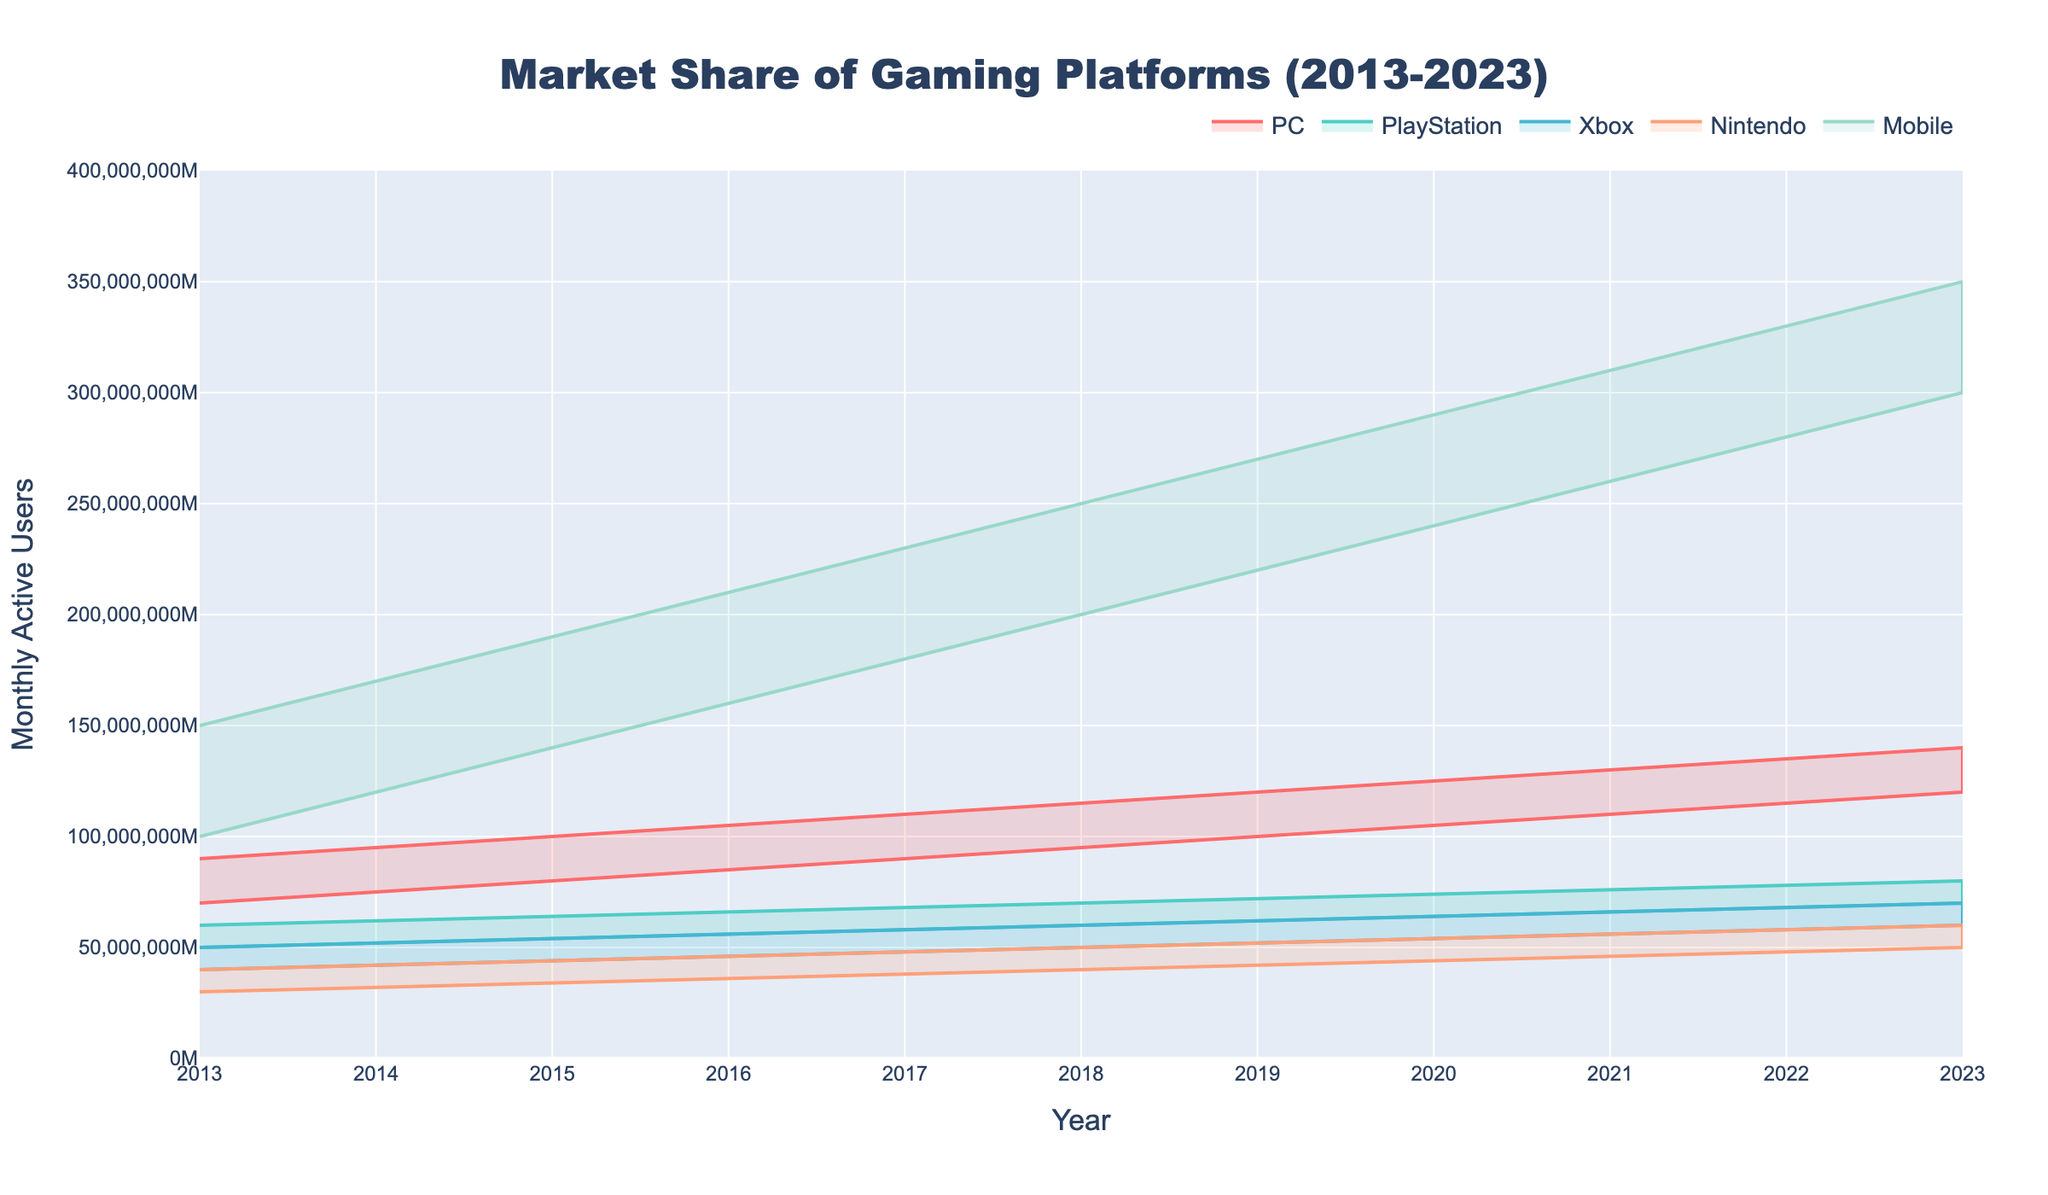Which platform has the highest maximum monthly active users in 2023? Looking at the plot for the year 2023, the Mobile platform's range extends up to 350 million monthly active users, which is the highest among all platforms.
Answer: Mobile What is the total range of monthly active users for the PC platform in 2020? For the PC platform in 2020, the range of monthly active users is from 105 million to 125 million. The total range is the difference between the maximum and minimum values: 125 million - 105 million.
Answer: 20 million Which platform showed the highest growth in maximum monthly active users from 2013 to 2023? By comparing the maximum monthly active users for each platform between 2013 and 2023, Mobile went from 150 million to 350 million, representing a growth of 200 million users, which is the highest growth among all platforms.
Answer: Mobile How much did the minimum monthly active users for the Nintendo platform increase from 2017 to 2020? For Nintendo, the minimum monthly active users were 38 million in 2017 and 44 million in 2020. The increase is calculated as 44 million - 38 million.
Answer: 6 million In which year did the PlayStation platform reach a minimum monthly active user count of 60 million? Examining the PlayStation area for a minimum of 60 million monthly active users, it occurred in the year 2018.
Answer: 2018 What was the minimum user range for Xbox in 2015, and how does it compare to Nintendo's minimum user range in the same year? The minimum monthly active users for Xbox in 2015 were 44 million, and for Nintendo, it was 34 million. Comparing the two, Xbox had 10 million more users than Nintendo.
Answer: 10 million more Which platform had the smallest growth in maximum monthly active users between 2013 and 2023? By comparing growth for all platforms: PC grew by 50 million, PlayStation by 20 million, Xbox by 20 million, Nintendo by 20 million, and Mobile by 200 million, PlayStation, Xbox, and Nintendo all had the smallest growth of 20 million each.
Answer: PlayStation, Xbox, and Nintendo What was the range of monthly active users for Mobile in 2016? The range for Mobile in 2016 extends from 160 million to 210 million monthly active users.
Answer: 50 million Is there any platform that had overlapping maximum and minimum user ranges in 2021? Examining 2021 user ranges, no two platforms' minimum and maximum user ranges overlap with each other.
Answer: No 